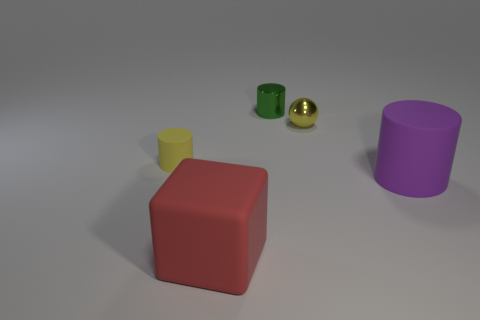Is the number of yellow shiny balls less than the number of blue rubber objects?
Your response must be concise. No. How many large purple matte objects have the same shape as the small green metal object?
Give a very brief answer. 1. What color is the other thing that is the same size as the purple rubber object?
Keep it short and to the point. Red. Is the number of objects that are behind the yellow matte thing the same as the number of big matte cubes that are behind the tiny green cylinder?
Your response must be concise. No. Are there any cyan cylinders that have the same size as the yellow shiny object?
Keep it short and to the point. No. The green metal object has what size?
Offer a terse response. Small. Are there the same number of yellow matte objects that are in front of the tiny yellow sphere and red rubber blocks?
Give a very brief answer. Yes. What number of other objects are the same color as the tiny matte thing?
Your response must be concise. 1. The small thing that is both on the left side of the metal sphere and to the right of the matte block is what color?
Your answer should be compact. Green. What size is the matte cylinder to the left of the rubber cylinder right of the matte cylinder behind the big purple cylinder?
Keep it short and to the point. Small. 